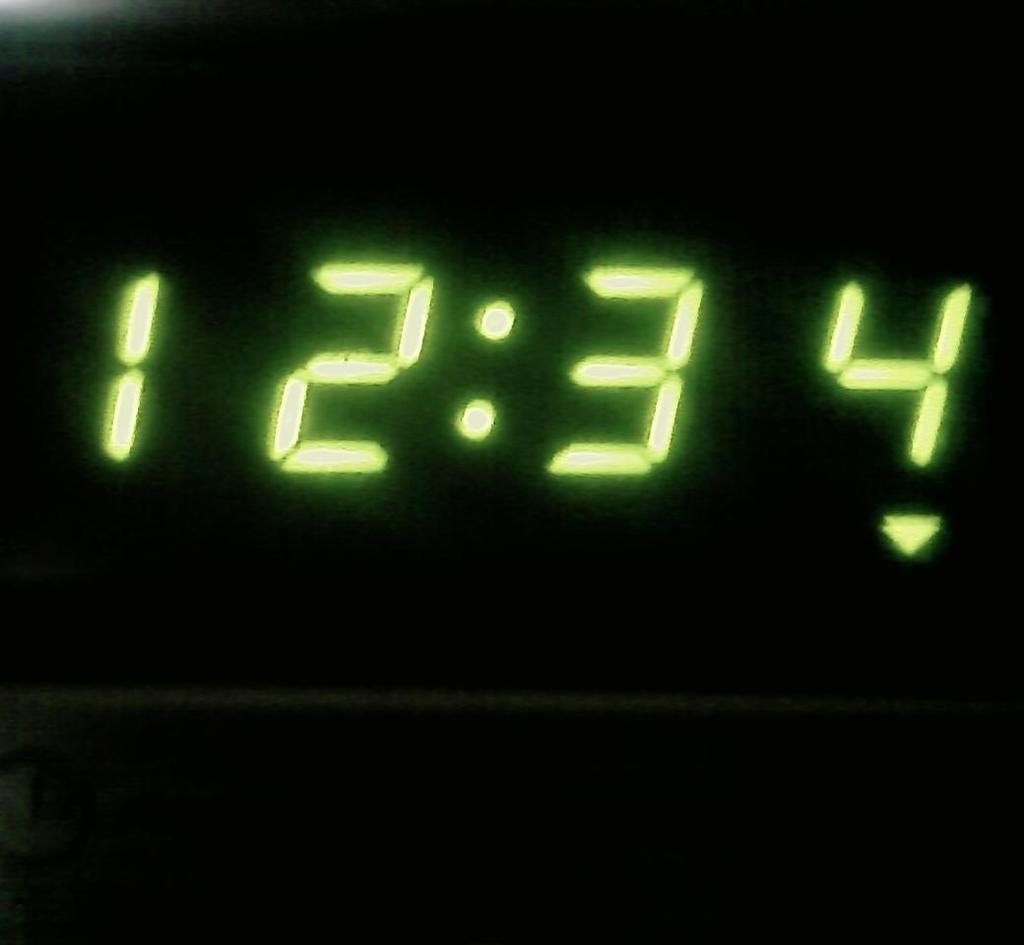<image>
Describe the image concisely. A green digital reading of 12:34 is displayed. 